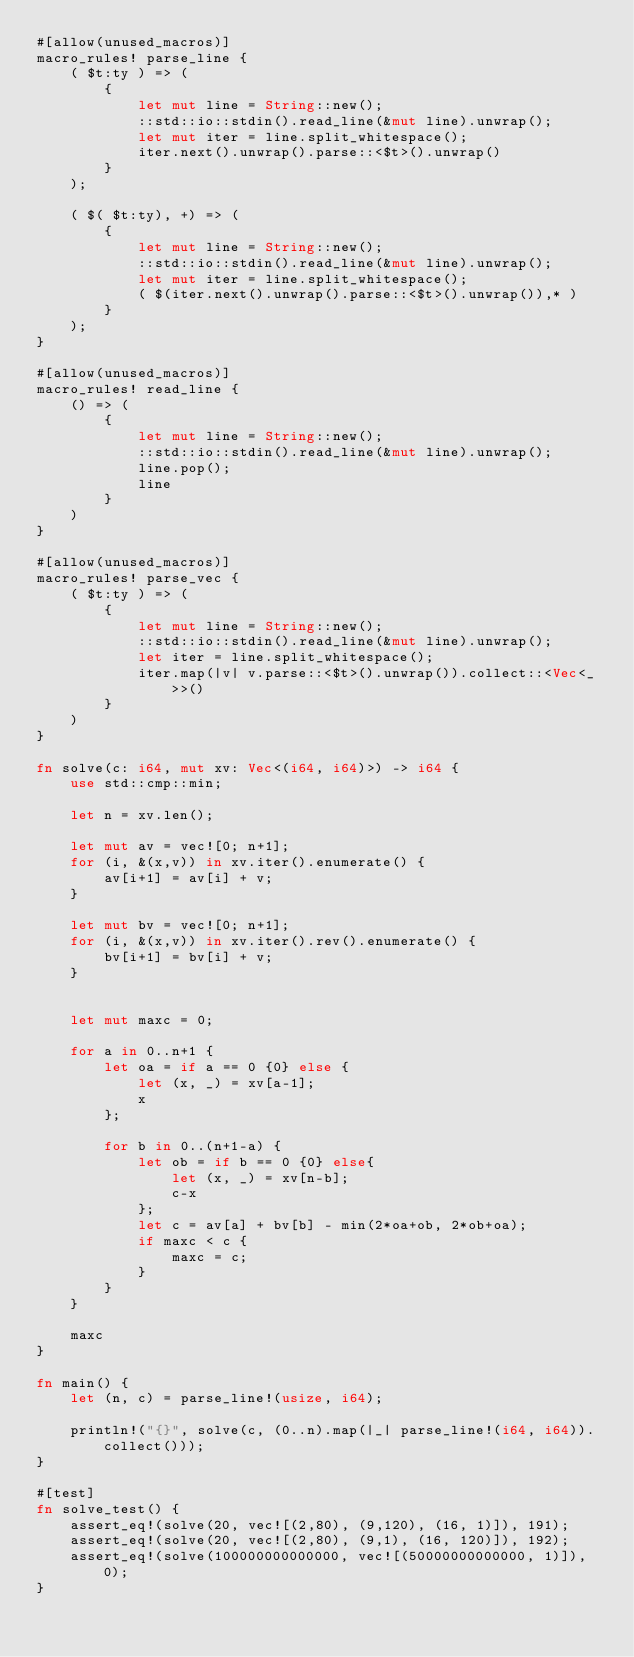Convert code to text. <code><loc_0><loc_0><loc_500><loc_500><_Rust_>#[allow(unused_macros)]
macro_rules! parse_line {
    ( $t:ty ) => (
        {
            let mut line = String::new();
            ::std::io::stdin().read_line(&mut line).unwrap();
            let mut iter = line.split_whitespace();
            iter.next().unwrap().parse::<$t>().unwrap()
        }
    );

    ( $( $t:ty), +) => (
        {
            let mut line = String::new();
            ::std::io::stdin().read_line(&mut line).unwrap();
            let mut iter = line.split_whitespace();
            ( $(iter.next().unwrap().parse::<$t>().unwrap()),* )
        }
    );
}

#[allow(unused_macros)]
macro_rules! read_line {
    () => (
        {
            let mut line = String::new();
            ::std::io::stdin().read_line(&mut line).unwrap();
            line.pop();
            line
        }
    )
}

#[allow(unused_macros)]
macro_rules! parse_vec {
    ( $t:ty ) => (
        {
            let mut line = String::new();
            ::std::io::stdin().read_line(&mut line).unwrap();
            let iter = line.split_whitespace();
            iter.map(|v| v.parse::<$t>().unwrap()).collect::<Vec<_>>()
        }
    )
}

fn solve(c: i64, mut xv: Vec<(i64, i64)>) -> i64 {
    use std::cmp::min;

    let n = xv.len();

    let mut av = vec![0; n+1];
    for (i, &(x,v)) in xv.iter().enumerate() {
        av[i+1] = av[i] + v;
    }

    let mut bv = vec![0; n+1];
    for (i, &(x,v)) in xv.iter().rev().enumerate() {
        bv[i+1] = bv[i] + v;
    }


    let mut maxc = 0;

    for a in 0..n+1 {
        let oa = if a == 0 {0} else {
            let (x, _) = xv[a-1];
            x
        };

        for b in 0..(n+1-a) {
            let ob = if b == 0 {0} else{
                let (x, _) = xv[n-b];
                c-x
            };
            let c = av[a] + bv[b] - min(2*oa+ob, 2*ob+oa);
            if maxc < c {
                maxc = c;
            }
        }
    }

    maxc
}

fn main() {
    let (n, c) = parse_line!(usize, i64);

    println!("{}", solve(c, (0..n).map(|_| parse_line!(i64, i64)).collect()));
}

#[test]
fn solve_test() {
    assert_eq!(solve(20, vec![(2,80), (9,120), (16, 1)]), 191);
    assert_eq!(solve(20, vec![(2,80), (9,1), (16, 120)]), 192);
    assert_eq!(solve(100000000000000, vec![(50000000000000, 1)]), 0);
}
</code> 